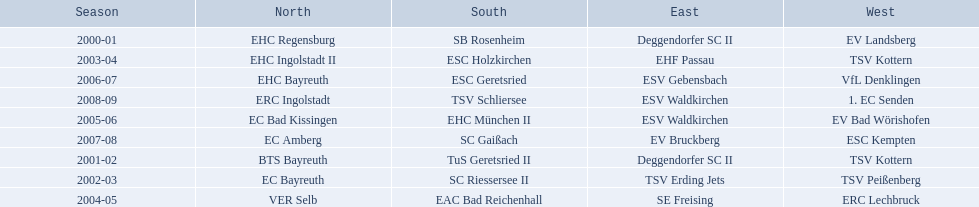Which teams have won in the bavarian ice hockey leagues between 2000 and 2009? EHC Regensburg, SB Rosenheim, Deggendorfer SC II, EV Landsberg, BTS Bayreuth, TuS Geretsried II, TSV Kottern, EC Bayreuth, SC Riessersee II, TSV Erding Jets, TSV Peißenberg, EHC Ingolstadt II, ESC Holzkirchen, EHF Passau, TSV Kottern, VER Selb, EAC Bad Reichenhall, SE Freising, ERC Lechbruck, EC Bad Kissingen, EHC München II, ESV Waldkirchen, EV Bad Wörishofen, EHC Bayreuth, ESC Geretsried, ESV Gebensbach, VfL Denklingen, EC Amberg, SC Gaißach, EV Bruckberg, ESC Kempten, ERC Ingolstadt, TSV Schliersee, ESV Waldkirchen, 1. EC Senden. Which of these winning teams have won the north? EHC Regensburg, BTS Bayreuth, EC Bayreuth, EHC Ingolstadt II, VER Selb, EC Bad Kissingen, EHC Bayreuth, EC Amberg, ERC Ingolstadt. Which of the teams that won the north won in the 2000/2001 season? EHC Regensburg. 